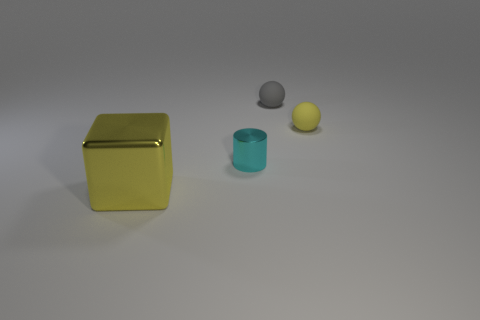How many tiny cylinders have the same color as the big metal thing?
Make the answer very short. 0. What shape is the gray thing?
Your answer should be very brief. Sphere. There is a object that is both in front of the yellow rubber thing and behind the big metallic cube; what color is it?
Offer a very short reply. Cyan. What is the material of the gray sphere?
Your answer should be compact. Rubber. There is a shiny object in front of the cyan metal cylinder; what is its shape?
Provide a succinct answer. Cube. What color is the ball that is the same size as the gray thing?
Your answer should be very brief. Yellow. Do the yellow object that is right of the big metal object and the small gray ball have the same material?
Provide a succinct answer. Yes. There is a object that is both on the right side of the yellow metallic cube and on the left side of the gray sphere; how big is it?
Provide a succinct answer. Small. How big is the matte thing in front of the small gray object?
Provide a short and direct response. Small. The yellow thing behind the metal object left of the metal object that is behind the big metal thing is what shape?
Provide a short and direct response. Sphere. 